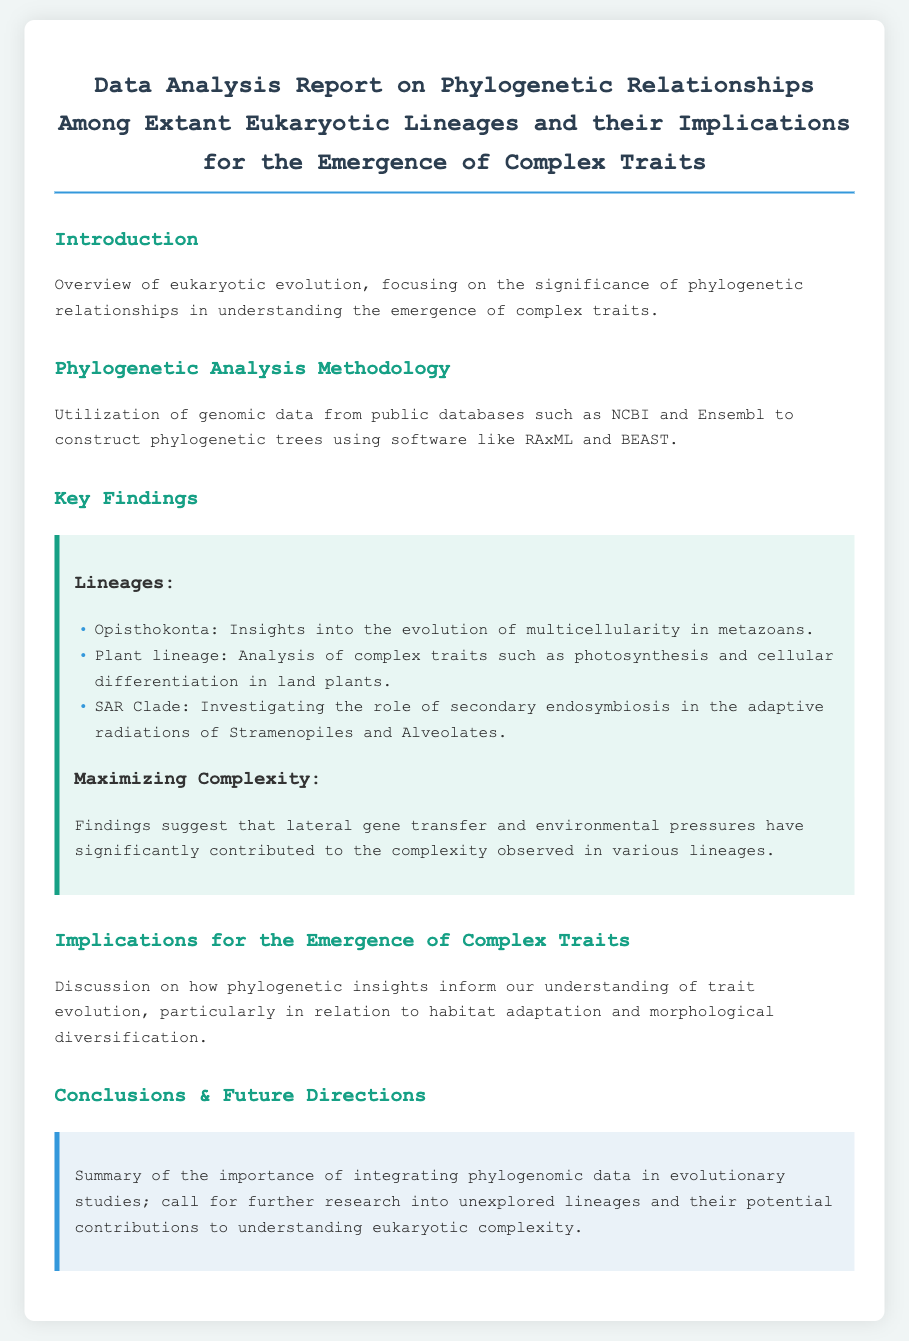What is the title of the document? The title is explicitly stated at the beginning of the document, summarizing the main topic of the report.
Answer: Data Analysis Report on Phylogenetic Relationships Among Extant Eukaryotic Lineages and their Implications for the Emergence of Complex Traits What software was used to construct phylogenetic trees? The document clearly mentions the specific software applications utilized for phylogenetic analysis in the methodology section.
Answer: RAxML and BEAST Which lineage is discussed in relation to multicellularity? The report indicates the specific lineage associated with insights into the evolution of multicellularity as one of the key findings.
Answer: Opisthokonta What role does the SAR Clade investigate? The investigation mentioned in the document relates to the impact of specific evolutionary events on adaptive radiations, which can be found in the findings section.
Answer: Secondary endosymbiosis What is the main focus of the Introduction section? The introduction outlines the broader context of the research, describing what it aims to address regarding evolutionary biology.
Answer: Overview of eukaryotic evolution How are lateral gene transfer and environmental pressures described in relation to complexity? These factors are mentioned as contributors to complexity in various lineages, which reflects a synthesis of different findings found in the report.
Answer: Significantly contributed What is the call to action in the Conclusions section? The conclusion section provides insight into future research directions that the report encourages, particularly related to a specific type of data integration.
Answer: Further research into unexplored lineages 